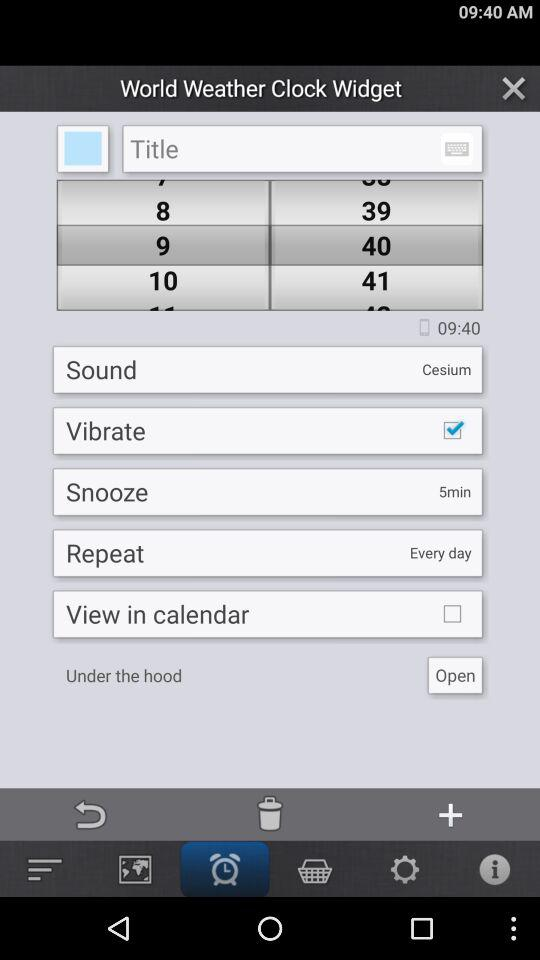What is the snooze time? The snooze time is 5 minutes. 